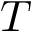Convert formula to latex. <formula><loc_0><loc_0><loc_500><loc_500>T</formula> 